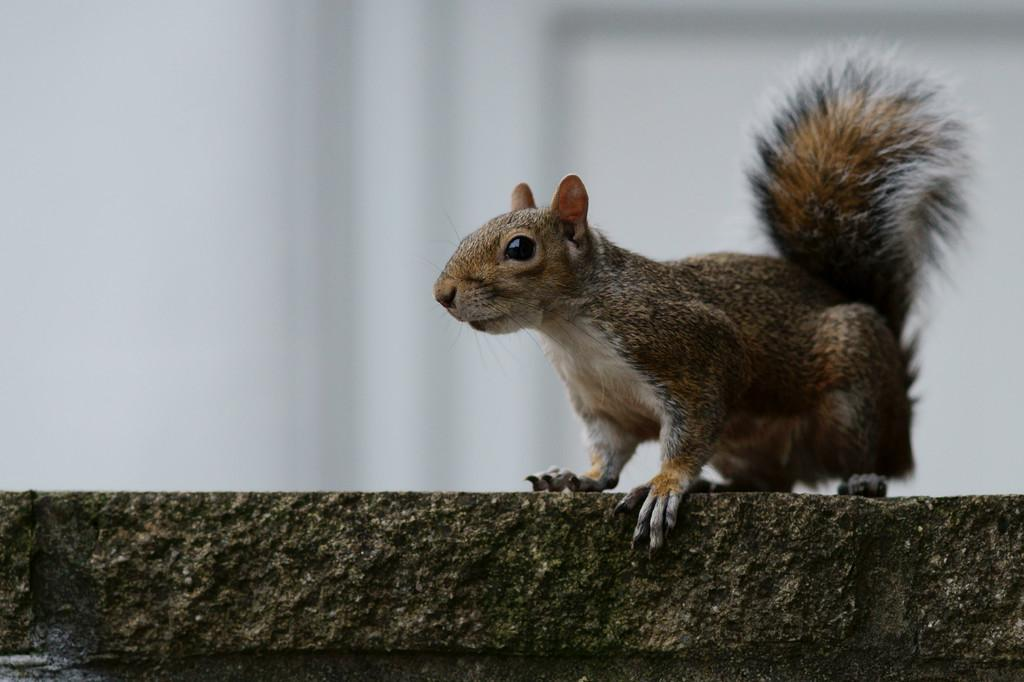What type of animal is in the image? There is a squirrel in the image. Where is the squirrel located? The squirrel is on a surface that resembles a wall. What color is the background of the image? The background of the image is white. How many ears of corn are visible in the image? There are no ears of corn present in the image. What type of trees can be seen in the background of the image? There is no background with trees in the image; the background is white. 